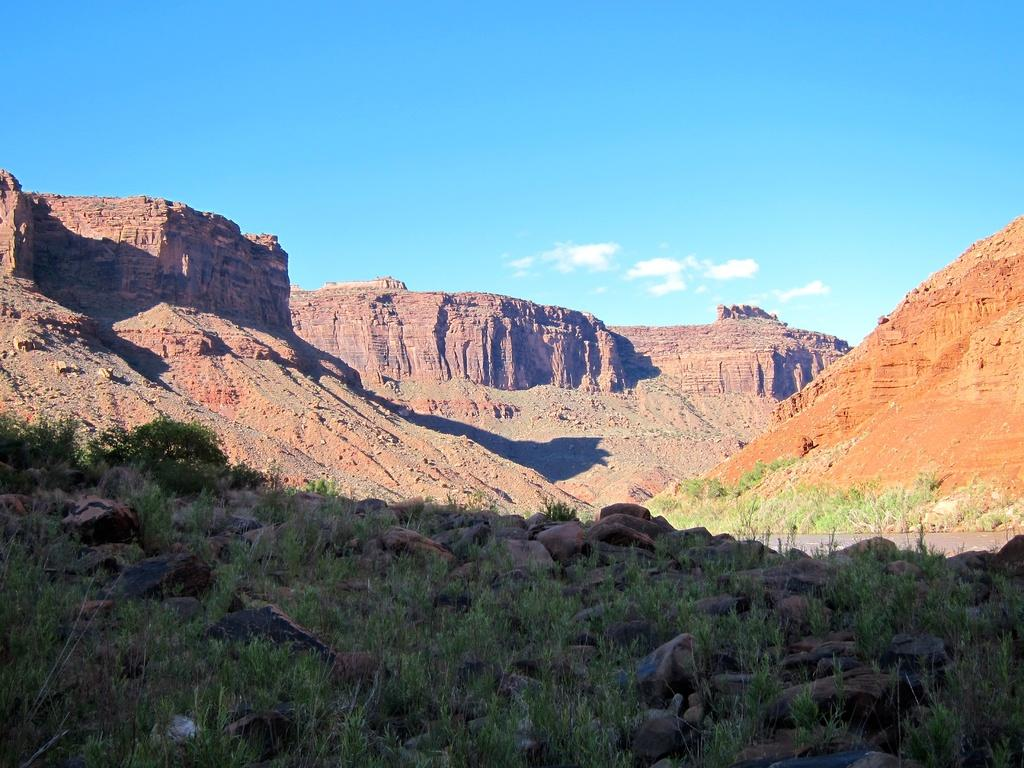What type of natural formation can be seen in the image? There are mountains in the image. What part of the sky is visible in the image? The sky is visible at the top of the image. What type of vegetation is present at the bottom of the image? There is grass at the bottom of the image. What type of geological feature can be seen in the image? There are rocks in the image. Can you describe the presence of water in the image? There might be water in the image, but it is not explicitly mentioned in the facts provided. What type of sponge is used to clean the mountains in the image? There is no sponge present in the image, and sponges are not used to clean mountains. 